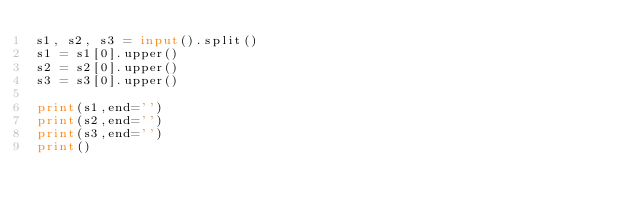Convert code to text. <code><loc_0><loc_0><loc_500><loc_500><_Python_>s1, s2, s3 = input().split()
s1 = s1[0].upper()
s2 = s2[0].upper()
s3 = s3[0].upper()

print(s1,end='')
print(s2,end='')
print(s3,end='')
print()</code> 